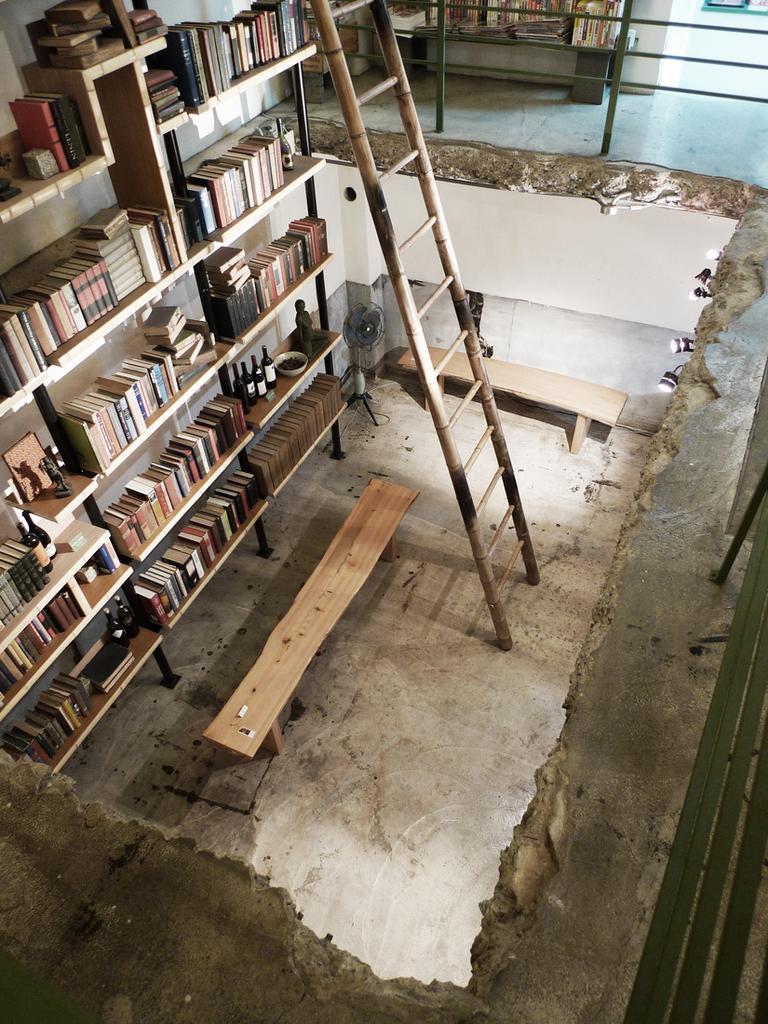In one or two sentences, can you explain what this image depicts? In this image I can see there is a book shelf with books, in-front of that there is a bench and ladder. 